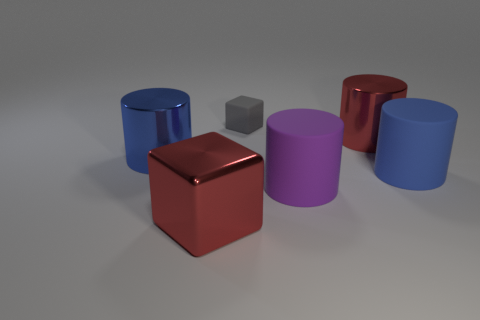What is the material of the cylinder that is the same color as the big block?
Your answer should be compact. Metal. Are there any other things that have the same size as the gray object?
Offer a terse response. No. There is a blue cylinder right of the gray matte cube; what is it made of?
Your answer should be very brief. Rubber. What number of objects are both behind the red metallic cylinder and to the right of the gray matte block?
Give a very brief answer. 0. There is a red cylinder that is the same size as the purple matte thing; what material is it?
Provide a succinct answer. Metal. Does the red thing that is on the right side of the gray rubber block have the same size as the blue object right of the red shiny cylinder?
Your response must be concise. Yes. There is a tiny gray rubber cube; are there any purple cylinders to the right of it?
Offer a terse response. Yes. What is the color of the big matte thing right of the large shiny cylinder to the right of the large red metal cube?
Offer a very short reply. Blue. Are there fewer cyan balls than large blue matte cylinders?
Make the answer very short. Yes. What number of other objects have the same shape as the large purple thing?
Your response must be concise. 3. 